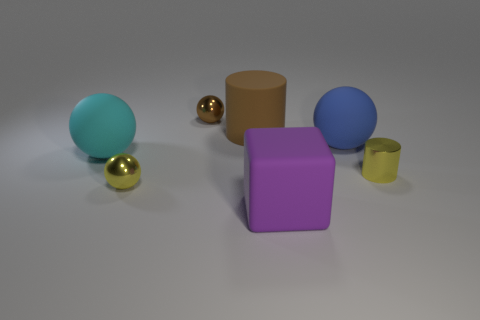Subtract 1 spheres. How many spheres are left? 3 Add 3 cyan rubber objects. How many objects exist? 10 Subtract all spheres. How many objects are left? 3 Add 4 small things. How many small things are left? 7 Add 6 large balls. How many large balls exist? 8 Subtract 0 purple spheres. How many objects are left? 7 Subtract all purple objects. Subtract all blocks. How many objects are left? 5 